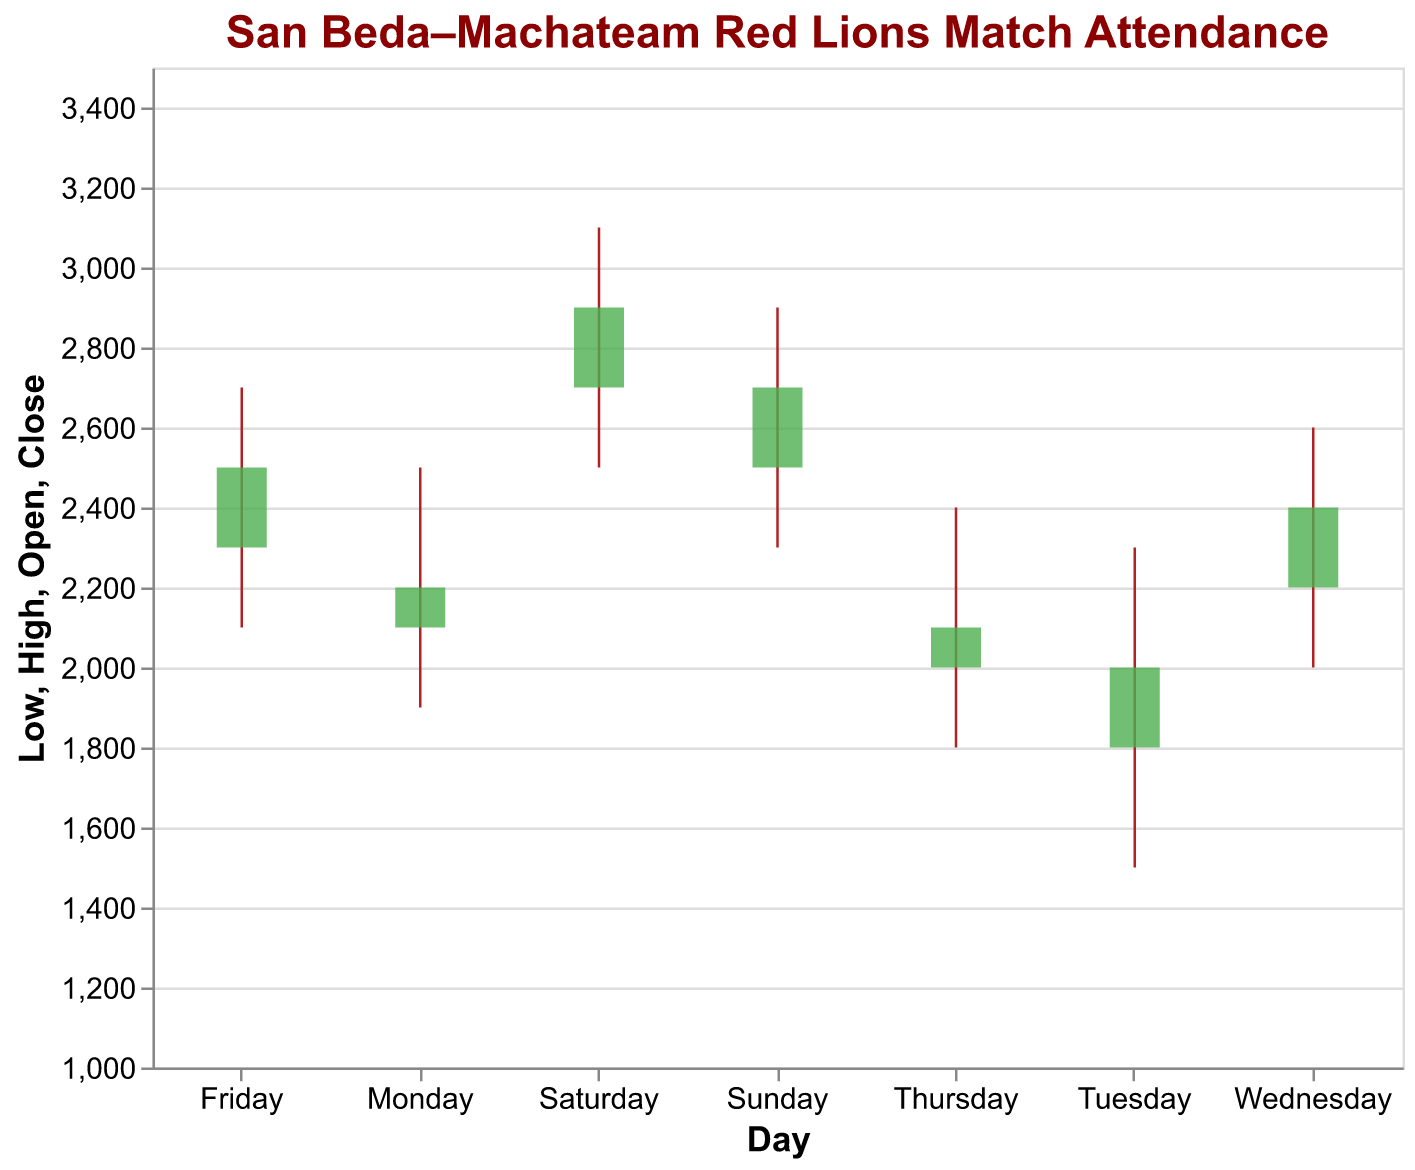How does the overall attendance trend look throughout the week? To determine the overall trend, observe the Open and Close values for each day from Monday to Sunday. This shows the beginning and end of the day's attendance. The attendance seems to increase gradually from Tuesday onwards, reaching its peak on Sunday.
Answer: Increasing Which day of the week has the highest peak attendance? The highest peak attendance is marked by the highest "High" value in the candlestick plot. By scanning the "High" values for each day, the highest value is 3100 on Saturday.
Answer: Saturday Which day has the lowest attendance at any point? The lowest attendance at any point is indicated by the "Low" value. By checking the "Low" values for each day, the lowest value is 1500 on Tuesday.
Answer: Tuesday On which days does the attendance increase from the Open to Close values? We need to compare the Open and Close values for each day. Attendance increases if the Close value is higher than the Open value. This is true for Monday, Wednesday, Friday, Saturday, and Sunday.
Answer: Monday, Wednesday, Friday, Saturday, Sunday What is the difference between the highest and lowest attendance recorded on Tuesday? To find this, subtract the "Low" value from the "High" value on Tuesday. The High and Low values are 2300 and 1500 respectively, so the difference is 2300 - 1500 = 800.
Answer: 800 How does the attendance variability on Friday compare to that on Thursday? Variability can be assessed by the range, which is High - Low. For Friday, it is 2700 - 2100 = 600, and for Thursday, it is 2400 - 1800 = 600. Both days have the same range of variability.
Answer: Same Which day shows the greatest increase in attendance from Open to Close? To find this, look at the difference between the Open and Close values where the Close is greater than the Open. The largest difference is (2400 - 2200) on Wednesday, which is 200.
Answer: Wednesday How many days have an attendance peak (High) above 2500? Count the number of days where the High value exceeds 2500. This occurs on Wednesday (2600), Friday (2700), Saturday (3100), and Sunday (2900). There are 4 such days.
Answer: 4 